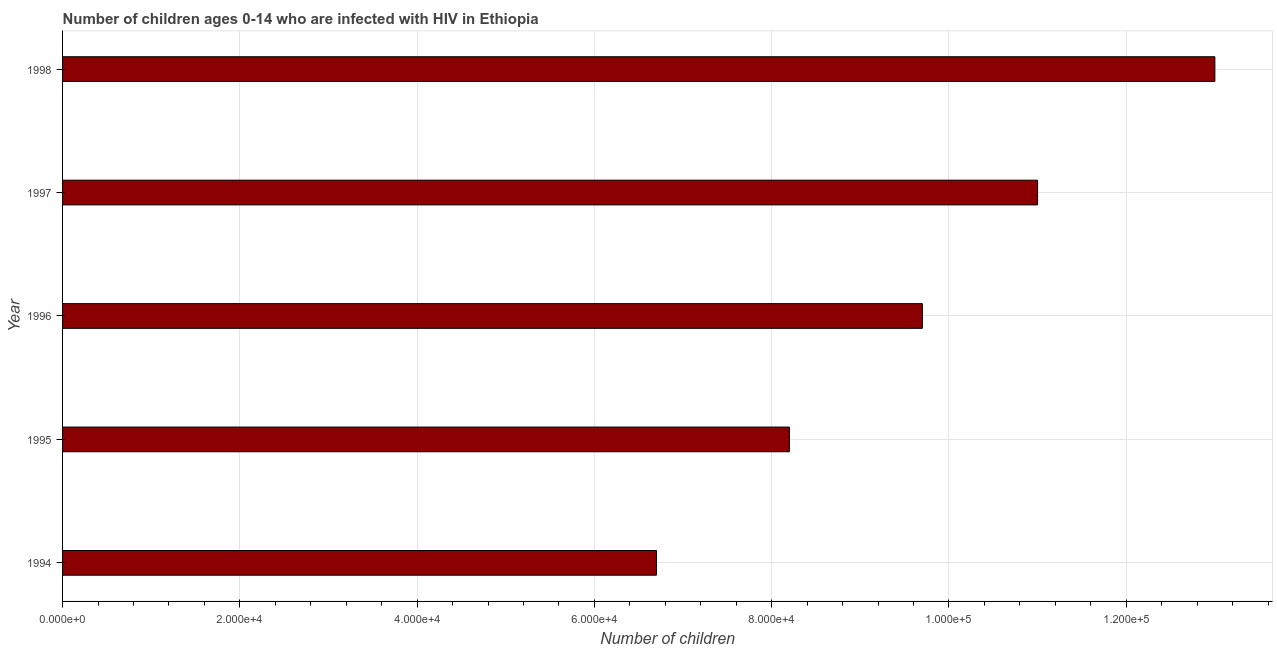Does the graph contain grids?
Ensure brevity in your answer.  Yes. What is the title of the graph?
Your response must be concise. Number of children ages 0-14 who are infected with HIV in Ethiopia. What is the label or title of the X-axis?
Make the answer very short. Number of children. What is the label or title of the Y-axis?
Provide a short and direct response. Year. What is the number of children living with hiv in 1998?
Give a very brief answer. 1.30e+05. Across all years, what is the maximum number of children living with hiv?
Keep it short and to the point. 1.30e+05. Across all years, what is the minimum number of children living with hiv?
Your response must be concise. 6.70e+04. What is the sum of the number of children living with hiv?
Your answer should be very brief. 4.86e+05. What is the difference between the number of children living with hiv in 1995 and 1996?
Your response must be concise. -1.50e+04. What is the average number of children living with hiv per year?
Offer a very short reply. 9.72e+04. What is the median number of children living with hiv?
Offer a terse response. 9.70e+04. In how many years, is the number of children living with hiv greater than 36000 ?
Your response must be concise. 5. Do a majority of the years between 1998 and 1995 (inclusive) have number of children living with hiv greater than 52000 ?
Offer a terse response. Yes. What is the ratio of the number of children living with hiv in 1994 to that in 1998?
Your answer should be compact. 0.52. Is the difference between the number of children living with hiv in 1995 and 1998 greater than the difference between any two years?
Provide a succinct answer. No. What is the difference between the highest and the second highest number of children living with hiv?
Provide a short and direct response. 2.00e+04. Is the sum of the number of children living with hiv in 1995 and 1997 greater than the maximum number of children living with hiv across all years?
Your answer should be compact. Yes. What is the difference between the highest and the lowest number of children living with hiv?
Provide a succinct answer. 6.30e+04. How many bars are there?
Keep it short and to the point. 5. Are all the bars in the graph horizontal?
Offer a terse response. Yes. How many years are there in the graph?
Provide a short and direct response. 5. What is the difference between two consecutive major ticks on the X-axis?
Make the answer very short. 2.00e+04. What is the Number of children in 1994?
Your answer should be compact. 6.70e+04. What is the Number of children of 1995?
Provide a succinct answer. 8.20e+04. What is the Number of children in 1996?
Your answer should be compact. 9.70e+04. What is the Number of children of 1997?
Your answer should be very brief. 1.10e+05. What is the Number of children of 1998?
Offer a very short reply. 1.30e+05. What is the difference between the Number of children in 1994 and 1995?
Make the answer very short. -1.50e+04. What is the difference between the Number of children in 1994 and 1997?
Your answer should be very brief. -4.30e+04. What is the difference between the Number of children in 1994 and 1998?
Keep it short and to the point. -6.30e+04. What is the difference between the Number of children in 1995 and 1996?
Your answer should be compact. -1.50e+04. What is the difference between the Number of children in 1995 and 1997?
Give a very brief answer. -2.80e+04. What is the difference between the Number of children in 1995 and 1998?
Your answer should be very brief. -4.80e+04. What is the difference between the Number of children in 1996 and 1997?
Ensure brevity in your answer.  -1.30e+04. What is the difference between the Number of children in 1996 and 1998?
Make the answer very short. -3.30e+04. What is the difference between the Number of children in 1997 and 1998?
Make the answer very short. -2.00e+04. What is the ratio of the Number of children in 1994 to that in 1995?
Your answer should be very brief. 0.82. What is the ratio of the Number of children in 1994 to that in 1996?
Make the answer very short. 0.69. What is the ratio of the Number of children in 1994 to that in 1997?
Offer a very short reply. 0.61. What is the ratio of the Number of children in 1994 to that in 1998?
Give a very brief answer. 0.52. What is the ratio of the Number of children in 1995 to that in 1996?
Your answer should be very brief. 0.84. What is the ratio of the Number of children in 1995 to that in 1997?
Offer a terse response. 0.74. What is the ratio of the Number of children in 1995 to that in 1998?
Provide a succinct answer. 0.63. What is the ratio of the Number of children in 1996 to that in 1997?
Provide a succinct answer. 0.88. What is the ratio of the Number of children in 1996 to that in 1998?
Give a very brief answer. 0.75. What is the ratio of the Number of children in 1997 to that in 1998?
Your response must be concise. 0.85. 